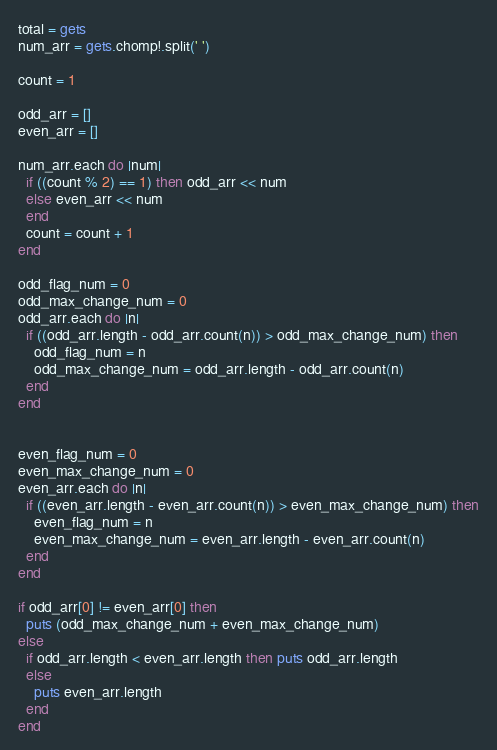Convert code to text. <code><loc_0><loc_0><loc_500><loc_500><_Ruby_>total = gets
num_arr = gets.chomp!.split(' ')

count = 1

odd_arr = []
even_arr = []

num_arr.each do |num|
  if ((count % 2) == 1) then odd_arr << num
  else even_arr << num
  end
  count = count + 1
end

odd_flag_num = 0
odd_max_change_num = 0
odd_arr.each do |n|
  if ((odd_arr.length - odd_arr.count(n)) > odd_max_change_num) then
    odd_flag_num = n
    odd_max_change_num = odd_arr.length - odd_arr.count(n)
  end
end


even_flag_num = 0
even_max_change_num = 0
even_arr.each do |n|
  if ((even_arr.length - even_arr.count(n)) > even_max_change_num) then
    even_flag_num = n
    even_max_change_num = even_arr.length - even_arr.count(n)
  end
end

if odd_arr[0] != even_arr[0] then
  puts (odd_max_change_num + even_max_change_num)
else
  if odd_arr.length < even_arr.length then puts odd_arr.length
  else
    puts even_arr.length
  end
end</code> 